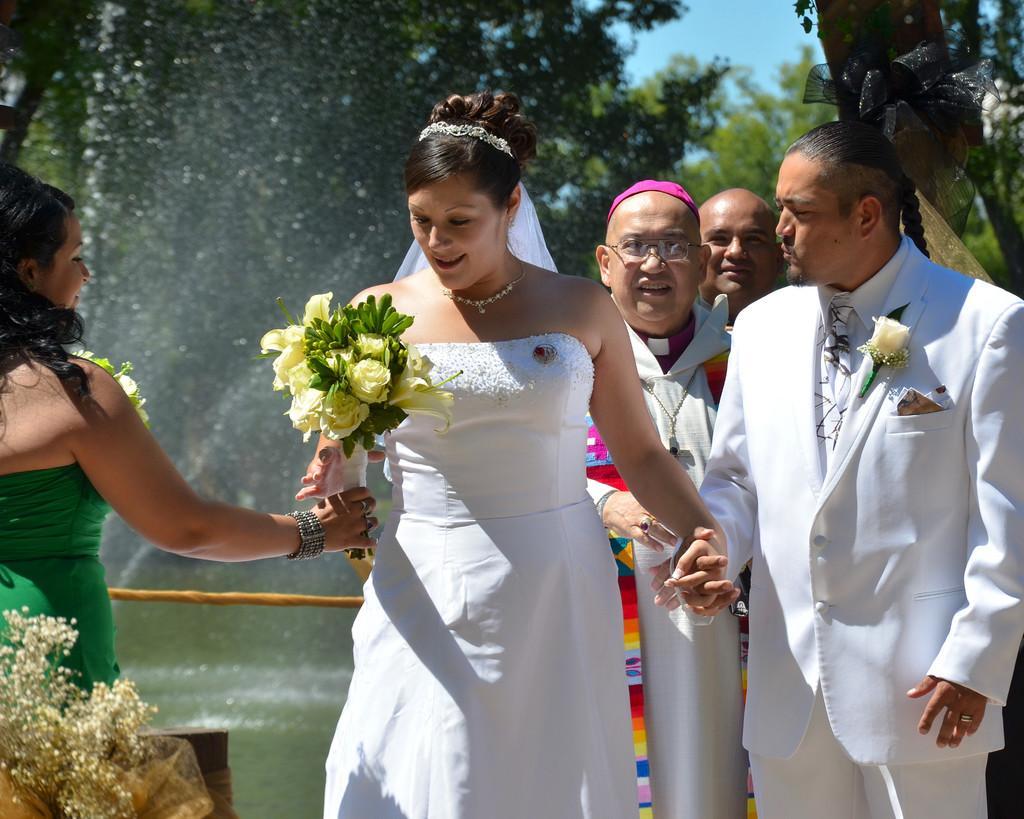Describe this image in one or two sentences. In the middle a beautiful woman is there, she wore white color dress. At the right side a man is holding her hand. He wore white color dress. This is the water. 